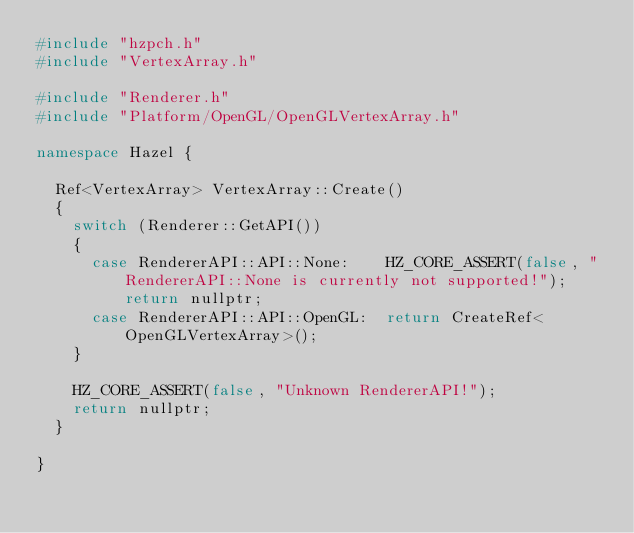<code> <loc_0><loc_0><loc_500><loc_500><_C++_>#include "hzpch.h"
#include "VertexArray.h"

#include "Renderer.h"
#include "Platform/OpenGL/OpenGLVertexArray.h"

namespace Hazel {

	Ref<VertexArray> VertexArray::Create()
	{
		switch (Renderer::GetAPI())
		{
			case RendererAPI::API::None:    HZ_CORE_ASSERT(false, "RendererAPI::None is currently not supported!"); return nullptr;
			case RendererAPI::API::OpenGL:  return CreateRef<OpenGLVertexArray>();
		}

		HZ_CORE_ASSERT(false, "Unknown RendererAPI!");
		return nullptr;
	}

}</code> 